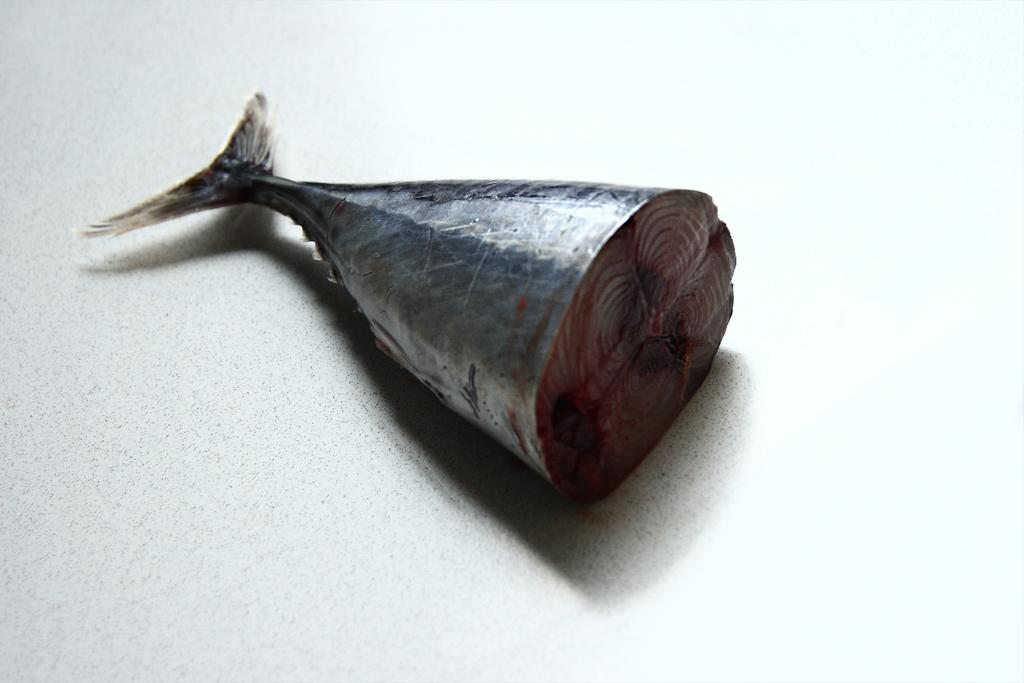What is the main subject of the image? The main subject of the image is a half-cut fish piece. Can you describe any specific features of the fish piece? Yes, the fish piece has a tail. What type of quiver is visible in the image? There is no quiver present in the image; it features a half-cut fish piece with a tail. How many hours can be seen in the image? There is no reference to time or hours in the image, as it only contains a half-cut fish piece with a tail. 